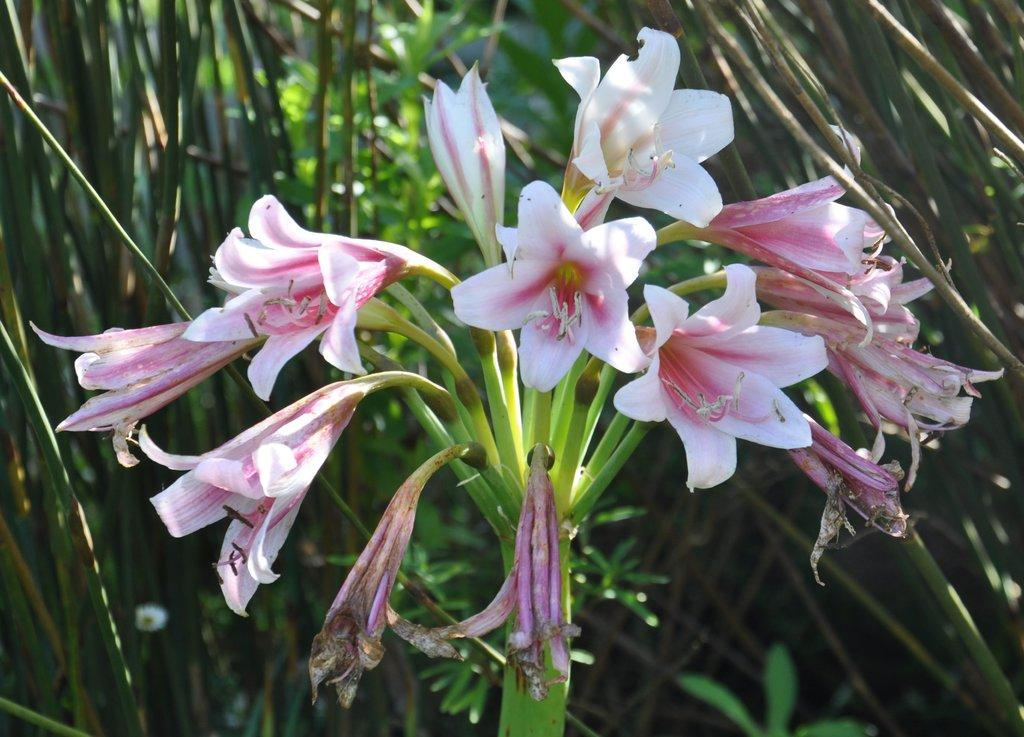What is the main subject in the middle of the image? There are flowers in the middle of the image. What can be seen in the background of the image? There is greenery in the background of the image. How many agreements can be seen between the flowers and the greenery in the image? There are no agreements present in the image, as it features flowers and greenery, not people or entities capable of making agreements. 